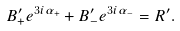<formula> <loc_0><loc_0><loc_500><loc_500>B ^ { \prime } _ { + } e ^ { 3 i \alpha _ { + } } + B ^ { \prime } _ { - } e ^ { 3 i \alpha _ { - } } = R ^ { \prime } .</formula> 